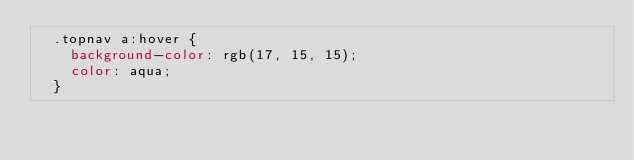<code> <loc_0><loc_0><loc_500><loc_500><_CSS_>  .topnav a:hover {
    background-color: rgb(17, 15, 15);
    color: aqua;
  }
  </code> 